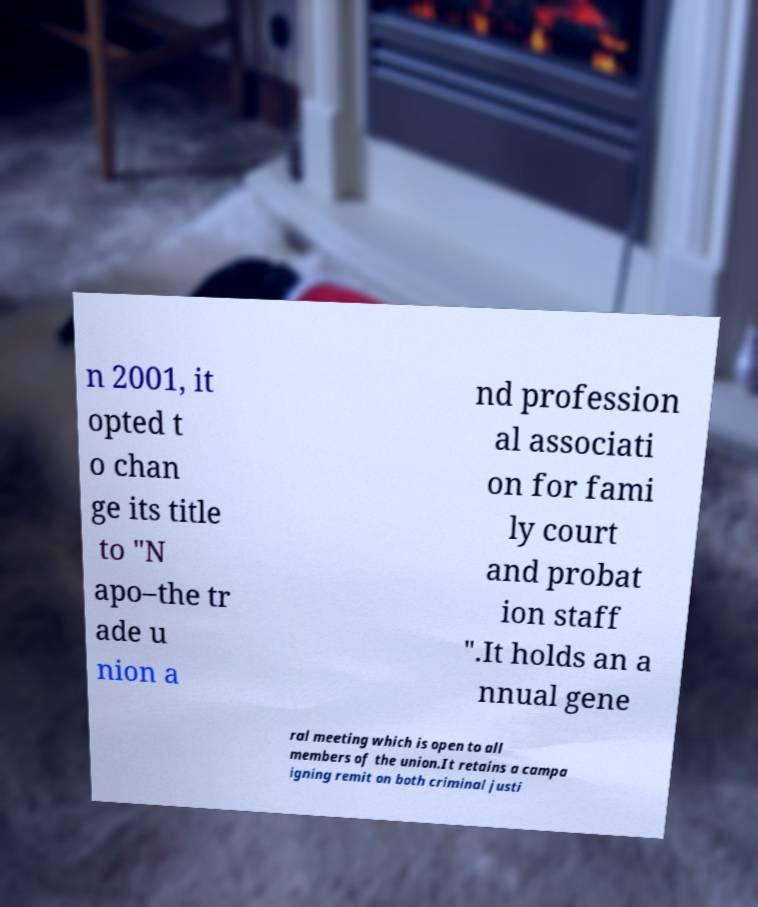Can you read and provide the text displayed in the image?This photo seems to have some interesting text. Can you extract and type it out for me? n 2001, it opted t o chan ge its title to "N apo–the tr ade u nion a nd profession al associati on for fami ly court and probat ion staff ".It holds an a nnual gene ral meeting which is open to all members of the union.It retains a campa igning remit on both criminal justi 